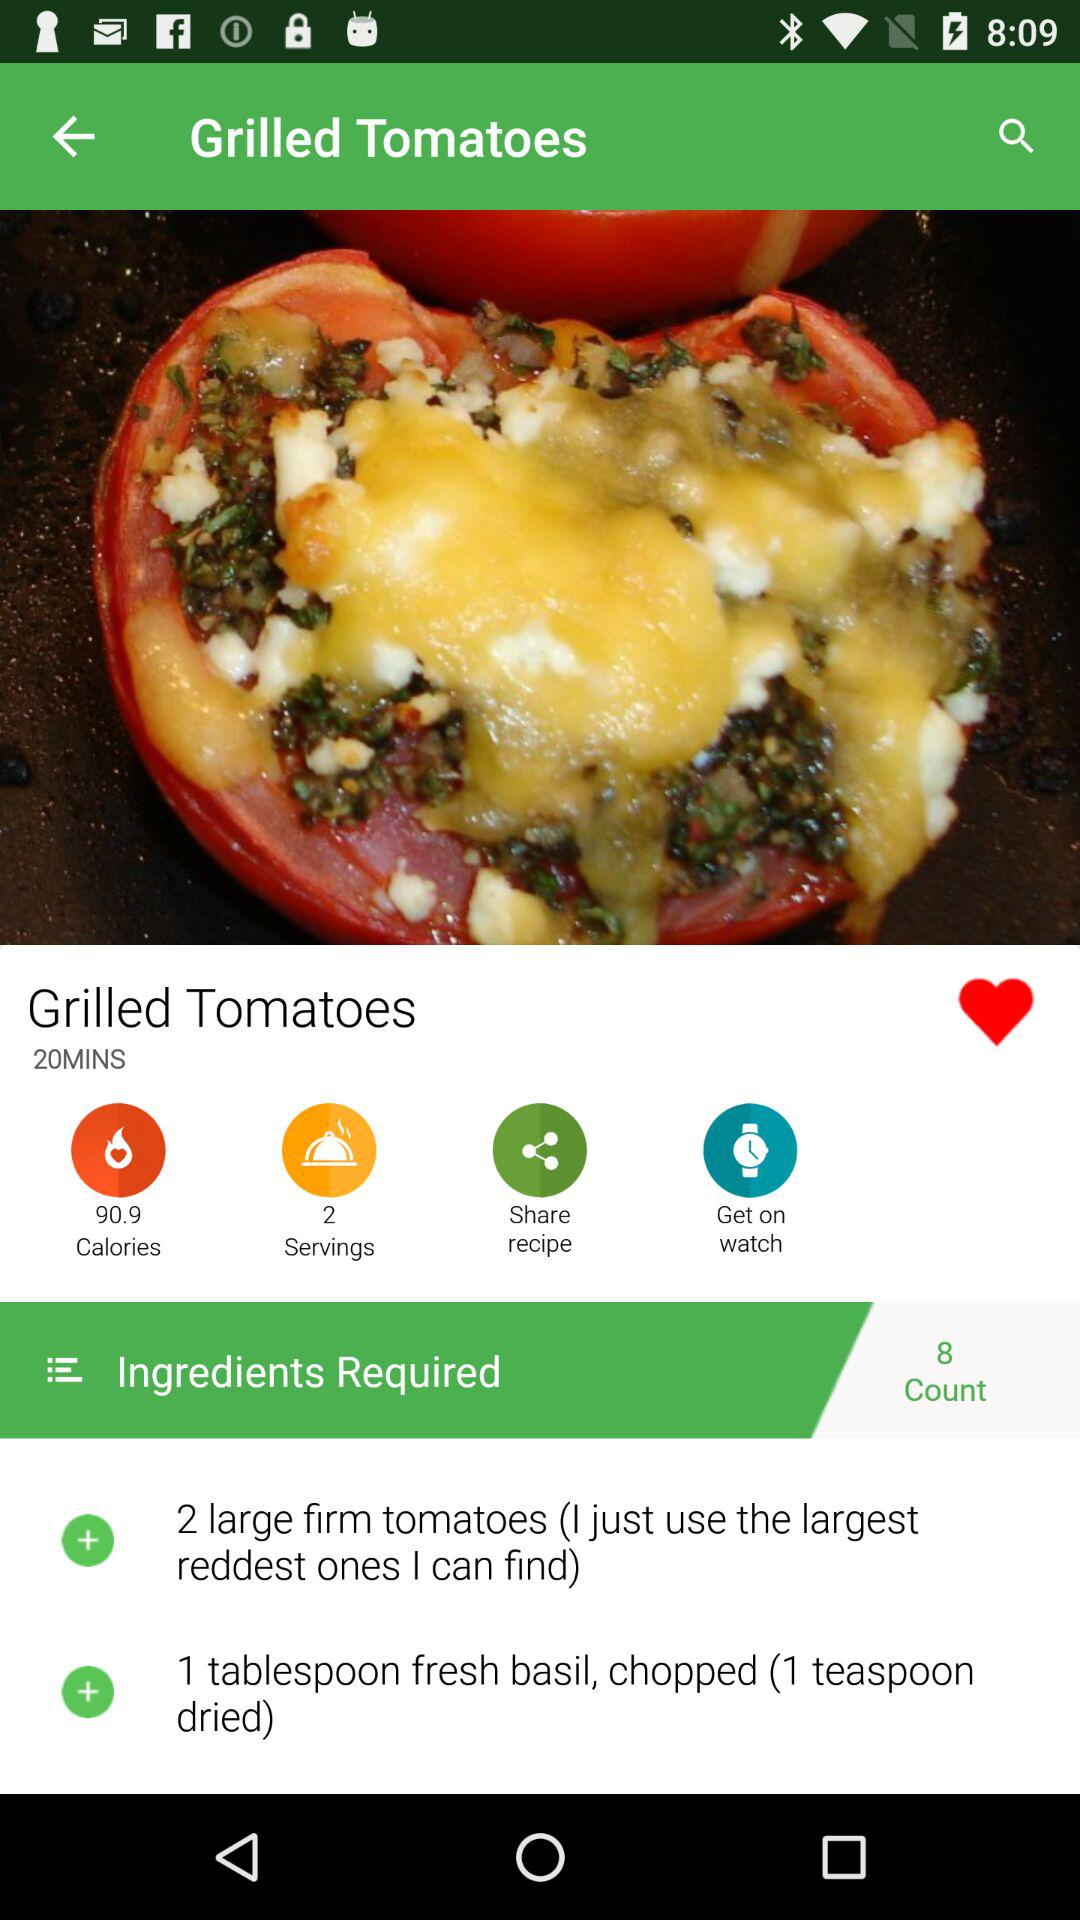How many calories do "Grilled Tomatoes" have? "Grilled Tomatoes" have 90.9 calories. 